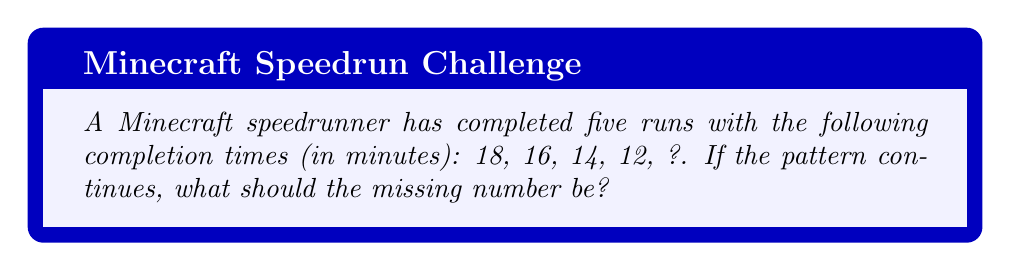Teach me how to tackle this problem. Let's approach this step-by-step:

1) First, we need to identify the pattern in the sequence. Let's look at the differences between consecutive numbers:

   18 → 16 (difference of -2)
   16 → 14 (difference of -2)
   14 → 12 (difference of -2)

2) We can see that each number in the sequence is 2 less than the previous number. This is an arithmetic sequence with a common difference of -2.

3) To find the next number in the sequence, we need to subtract 2 from the last given number:

   $12 - 2 = 10$

4) We can verify this by writing out the arithmetic sequence formula:

   $a_n = a_1 + (n-1)d$

   Where $a_n$ is the nth term, $a_1$ is the first term, n is the position of the term, and d is the common difference.

5) In this case:
   $a_1 = 18$ (first term)
   $d = -2$ (common difference)
   $n = 5$ (we're looking for the 5th term)

6) Plugging these into the formula:

   $a_5 = 18 + (5-1)(-2)$
   $a_5 = 18 + (-8)$
   $a_5 = 10$

Therefore, the missing number in the sequence is 10.
Answer: 10 